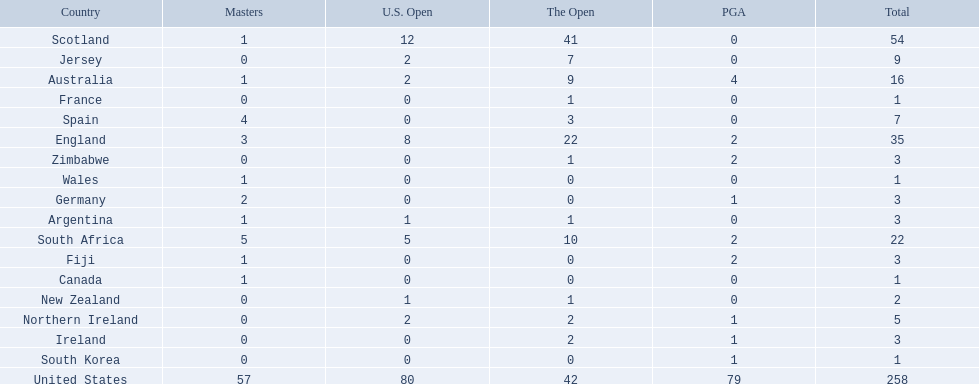Which of the countries listed are african? South Africa, Zimbabwe. Which of those has the least championship winning golfers? Zimbabwe. 